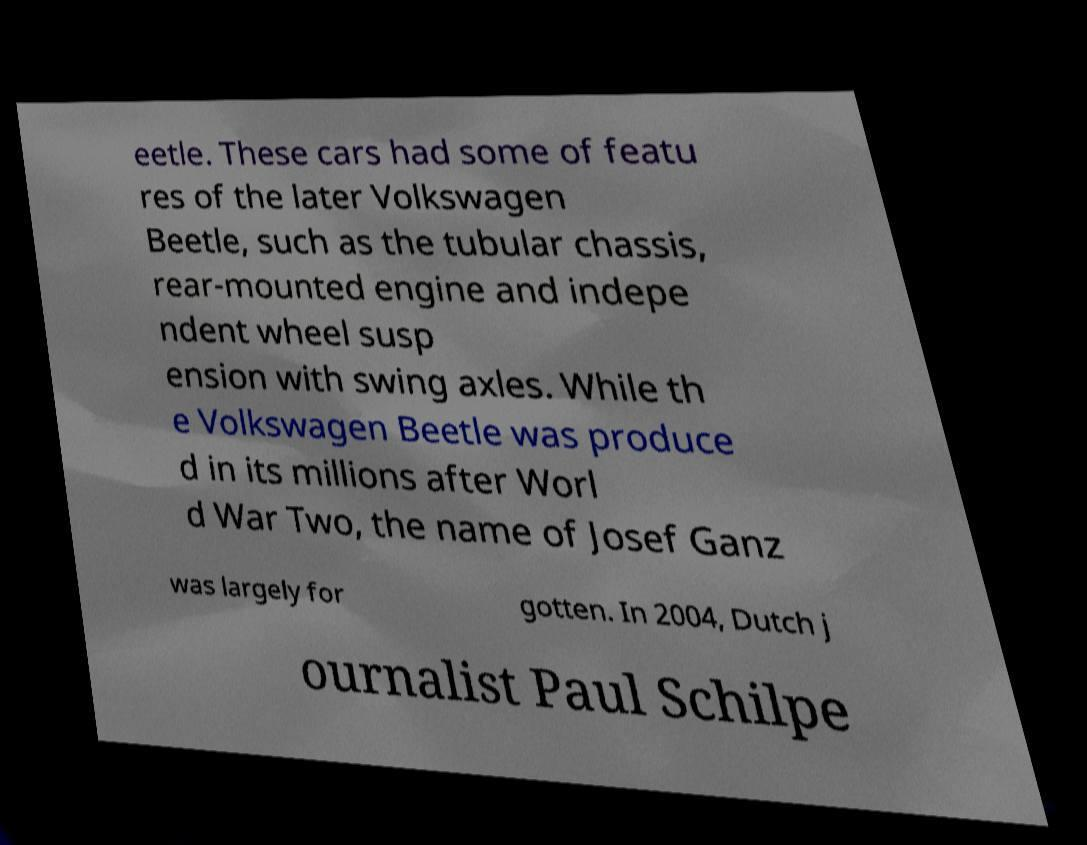For documentation purposes, I need the text within this image transcribed. Could you provide that? eetle. These cars had some of featu res of the later Volkswagen Beetle, such as the tubular chassis, rear-mounted engine and indepe ndent wheel susp ension with swing axles. While th e Volkswagen Beetle was produce d in its millions after Worl d War Two, the name of Josef Ganz was largely for gotten. In 2004, Dutch j ournalist Paul Schilpe 